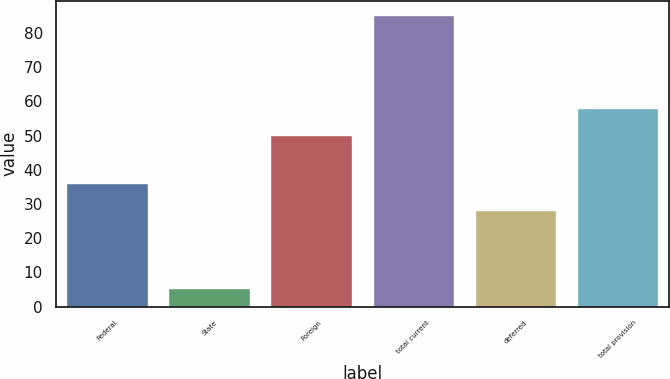Convert chart. <chart><loc_0><loc_0><loc_500><loc_500><bar_chart><fcel>Federal<fcel>State<fcel>Foreign<fcel>total current<fcel>deferred<fcel>total provision<nl><fcel>36.08<fcel>5.4<fcel>50.1<fcel>85.2<fcel>28.1<fcel>58.08<nl></chart> 